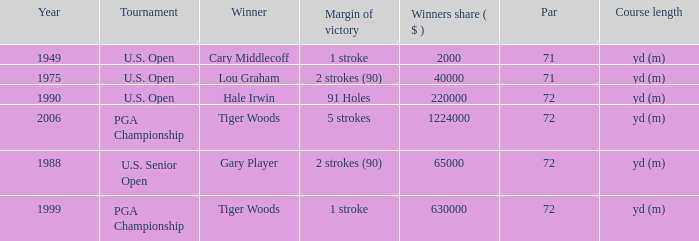When cary middlecoff is the winner how many pars are there? 1.0. 